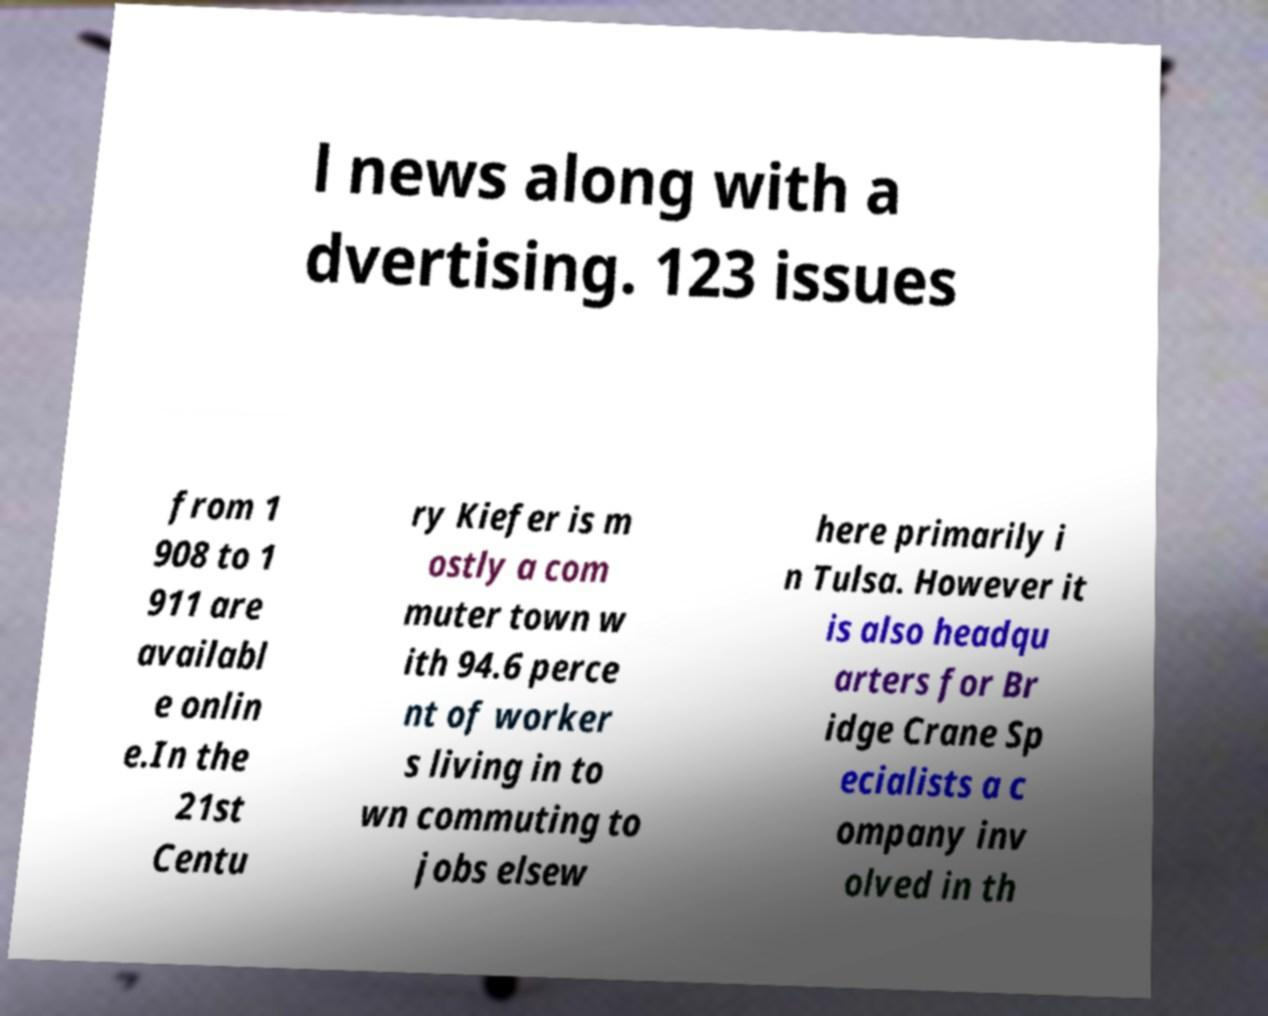Please read and relay the text visible in this image. What does it say? l news along with a dvertising. 123 issues from 1 908 to 1 911 are availabl e onlin e.In the 21st Centu ry Kiefer is m ostly a com muter town w ith 94.6 perce nt of worker s living in to wn commuting to jobs elsew here primarily i n Tulsa. However it is also headqu arters for Br idge Crane Sp ecialists a c ompany inv olved in th 